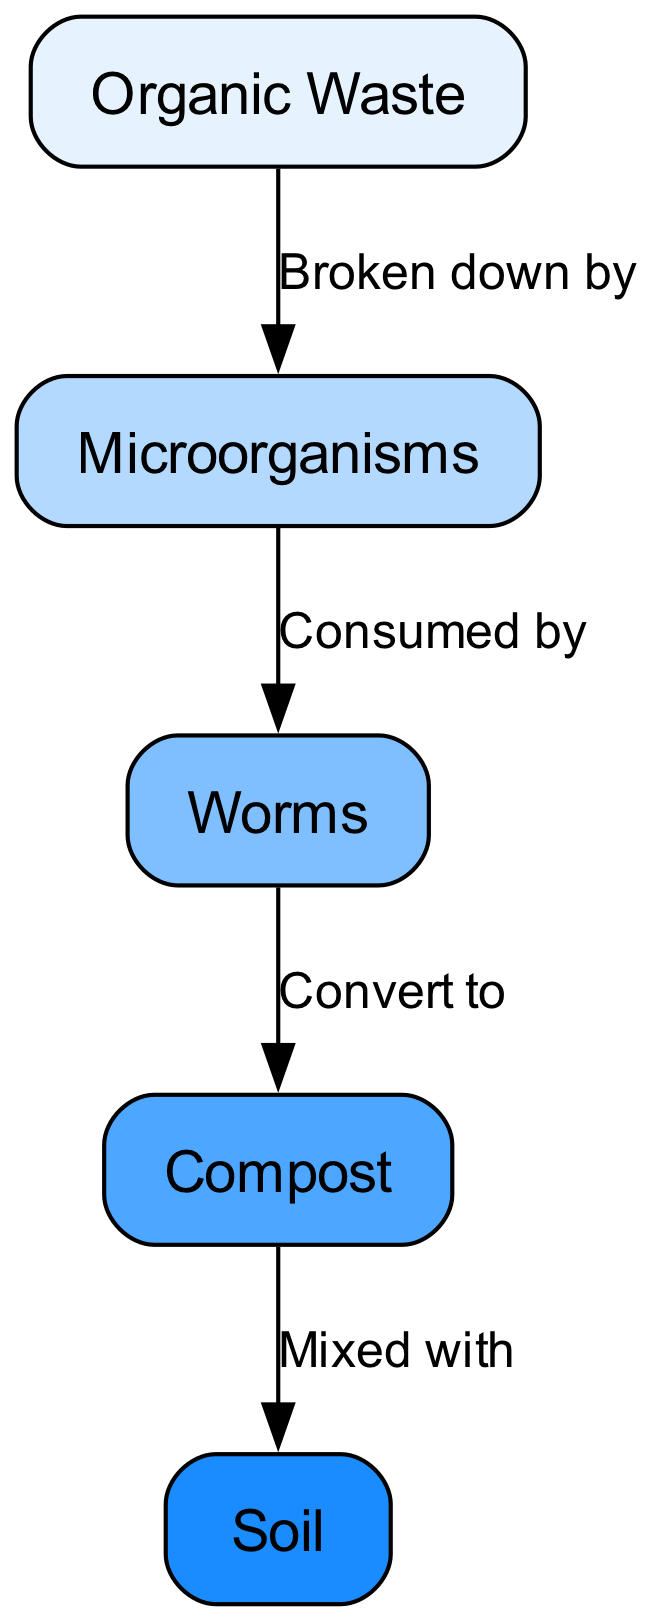What is the first node in the decomposition process? The first node listed in the diagram is "Organic Waste," which is the starting point of the decomposition process, as it initiates the flow to the next node, "Microorganisms."
Answer: Organic Waste How many nodes are present in the diagram? By counting the nodes displayed in the diagram, there are a total of five distinct nodes, which are Organic Waste, Microorganisms, Worms, Compost, and Soil.
Answer: 5 What consumes microorganisms in the process? The diagram indicates that Worms are the organisms that consume Microorganisms, as depicted in the directed edge labeling "Consumed by" leading from Microorganisms to Worms.
Answer: Worms What is produced from worms in the decomposition process? The diagram shows that Worms convert Microorganisms into Compost, represented by the edge labeled "Convert to” between the two nodes.
Answer: Compost What is the final product after the decomposition process? The last node in the flow of the diagram is "Soil," which is the end product after Compost is mixed with it, as illustrated by the edge labeled "Mixed with."
Answer: Soil Which node is broken down by microorganisms? The diagram clearly states that Organic Waste is broken down by Microorganisms, which is indicated in the edge labeled "Broken down by."
Answer: Organic Waste What type of relationship exists between compost and soil? The relationship depicted in the diagram shows that Compost is mixed with Soil, which is indicated by the edge labeled "Mixed with." This signifies a direct interaction between these two entities.
Answer: Mixed with What is the relationship flow from organic waste to soil? The flow starts with Organic Waste, which is broken down by Microorganisms, then consumed by Worms, converted into Compost, and finally mixed with Soil, following the edges in the order they appear in the diagram.
Answer: Organic Waste → Microorganisms → Worms → Compost → Soil How many edges are present in the diagram? The diagram contains four edges that connect the five nodes, providing the relationships and flow between them as described in the edges' labels.
Answer: 4 